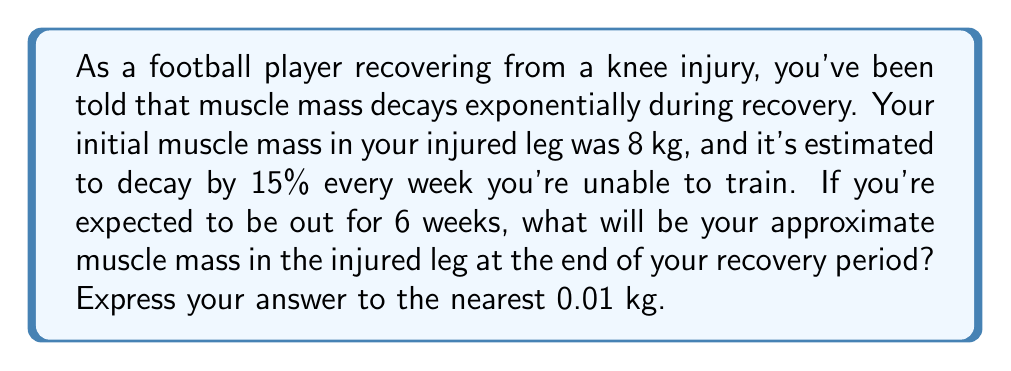Teach me how to tackle this problem. Let's approach this step-by-step:

1) First, we need to identify the components of our exponential decay function:
   - Initial value (A): 8 kg
   - Decay rate (r): 15% = 0.15
   - Time (t): 6 weeks

2) The general formula for exponential decay is:
   $$ A(t) = A_0(1-r)^t $$
   Where $A(t)$ is the amount at time t, $A_0$ is the initial amount, r is the decay rate, and t is the time.

3) Plugging in our values:
   $$ A(6) = 8(1-0.15)^6 $$

4) Simplify inside the parentheses:
   $$ A(6) = 8(0.85)^6 $$

5) Now we can calculate this:
   $$ A(6) = 8 * 0.85^6 $$
   $$ A(6) = 8 * 0.377695... $$
   $$ A(6) = 3.021560... $$

6) Rounding to the nearest 0.01 kg:
   $$ A(6) \approx 3.02 \text{ kg} $$
Answer: 3.02 kg 